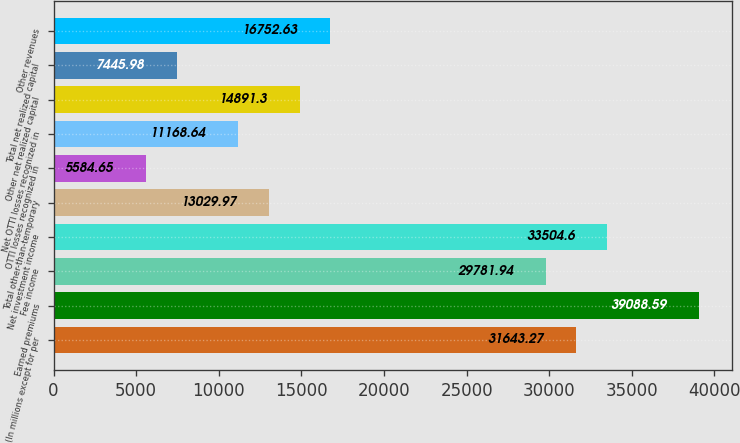Convert chart to OTSL. <chart><loc_0><loc_0><loc_500><loc_500><bar_chart><fcel>(In millions except for per<fcel>Earned premiums<fcel>Fee income<fcel>Net investment income<fcel>Total other-than-temporary<fcel>OTTI losses recognized in<fcel>Net OTTI losses recognized in<fcel>Other net realized capital<fcel>Total net realized capital<fcel>Other revenues<nl><fcel>31643.3<fcel>39088.6<fcel>29781.9<fcel>33504.6<fcel>13030<fcel>5584.65<fcel>11168.6<fcel>14891.3<fcel>7445.98<fcel>16752.6<nl></chart> 